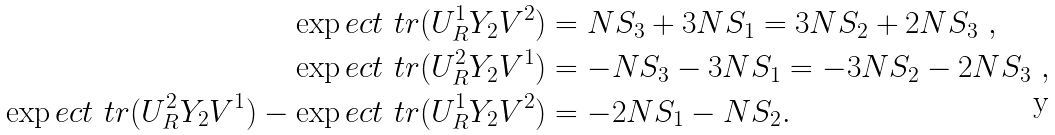Convert formula to latex. <formula><loc_0><loc_0><loc_500><loc_500>\exp e c t { \ t r ( U _ { R } ^ { 1 } Y _ { 2 } V ^ { 2 } ) } & = N S _ { 3 } + 3 N S _ { 1 } = 3 N S _ { 2 } + 2 N S _ { 3 } \ , \\ \exp e c t { \ t r ( U _ { R } ^ { 2 } Y _ { 2 } V ^ { 1 } ) } & = - N S _ { 3 } - 3 N S _ { 1 } = - 3 N S _ { 2 } - 2 N S _ { 3 } \ , \\ \exp e c t { \ t r ( U _ { R } ^ { 2 } Y _ { 2 } V ^ { 1 } ) } - \exp e c t { \ t r ( U _ { R } ^ { 1 } Y _ { 2 } V ^ { 2 } ) } & = - 2 N S _ { 1 } - N S _ { 2 } . \</formula> 